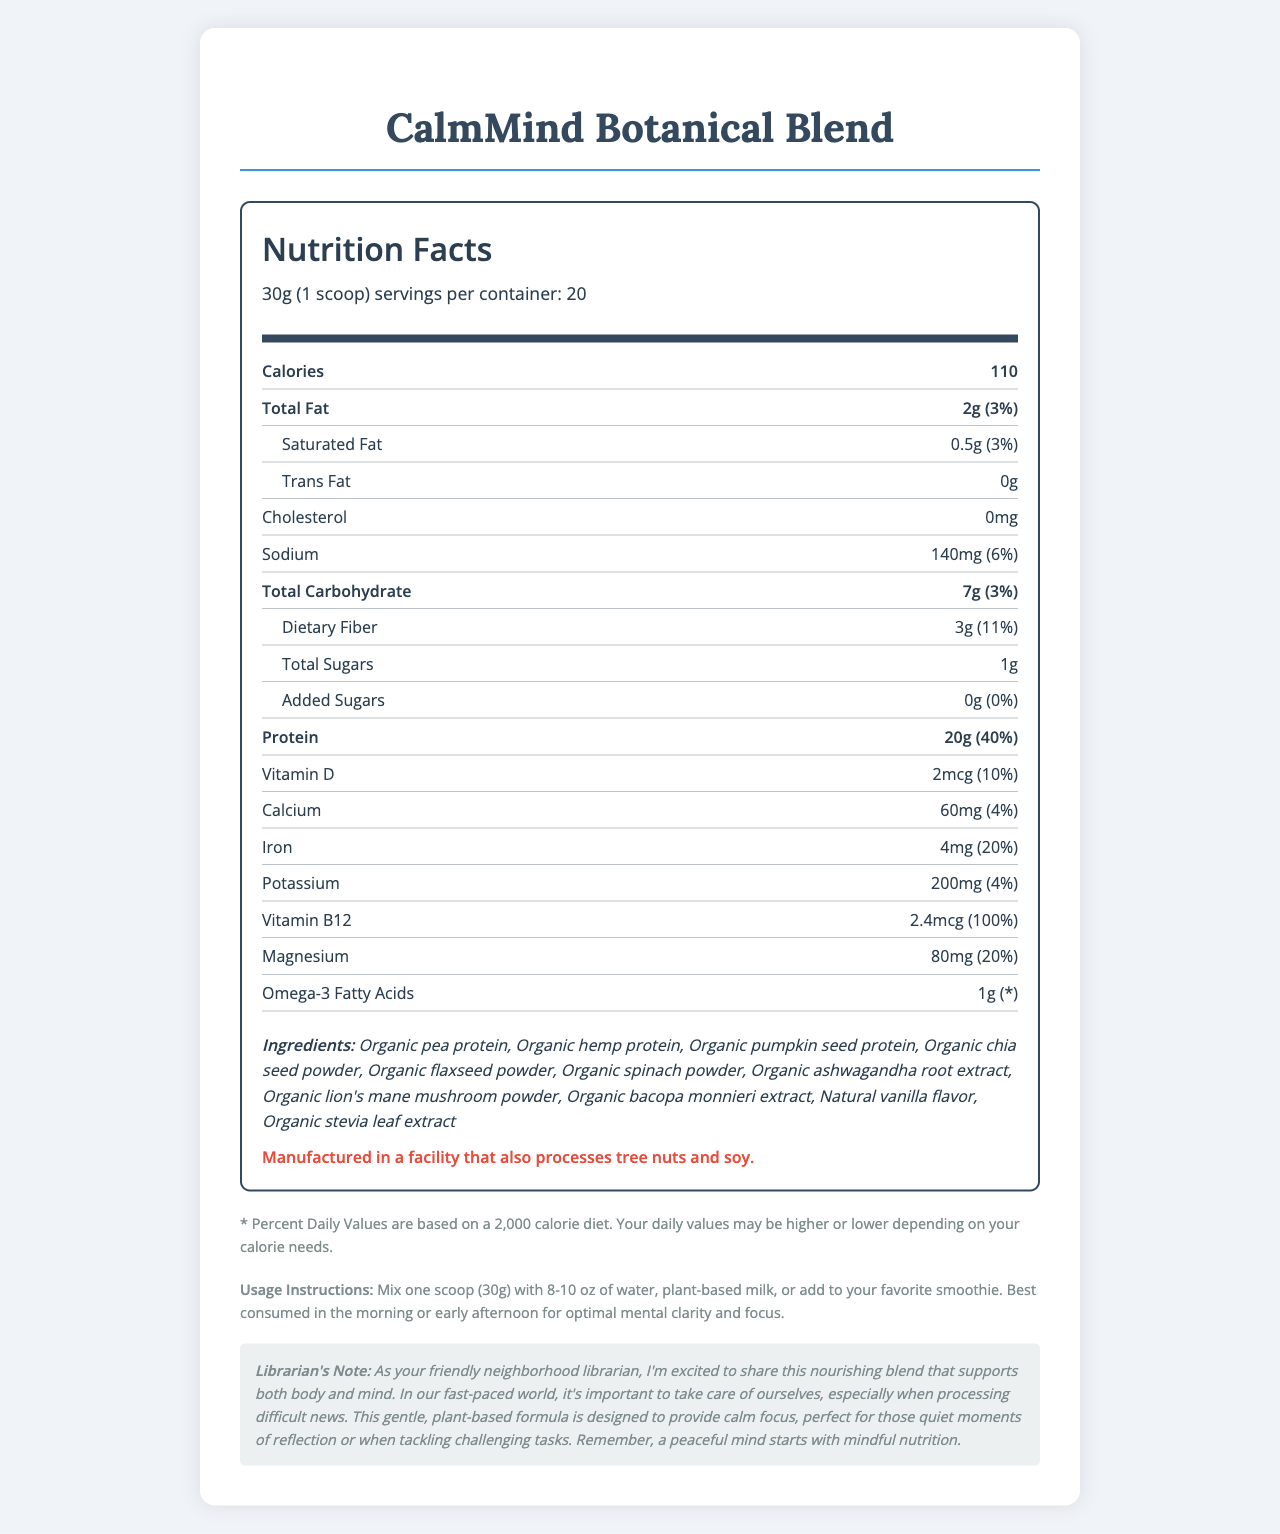who produces CalmMind Botanical Blend? The document does not provide information about the producer or manufacturer of CalmMind Botanical Blend.
Answer: Cannot be determined what is the serving size for CalmMind Botanical Blend? The document specifies that one serving of CalmMind Botanical Blend is 30 grams, which is equivalent to one scoop.
Answer: 30g (1 scoop) how many calories are in one serving of CalmMind Botanical Blend? The document states that there are 110 calories in one serving of CalmMind Botanical Blend.
Answer: 110 what is the total amount of protein per serving? The document indicates that one serving of CalmMind Botanical Blend contains 20 grams of protein.
Answer: 20g what percentage of the daily value for dietary fiber does one serving provide? The document shows that one serving provides 11% of the daily value for dietary fiber.
Answer: 11% how many servings are in one container of CalmMind Botanical Blend? The document indicates there are 20 servings per container.
Answer: 20 what is the amount of added sugars in CalmMind Botanical Blend per serving? The document states that there are no added sugars (0g) per serving.
Answer: 0g how much iron does one serving provide, and what is its daily value percentage? The document specifies that one serving contains 4mg of iron, which is 20% of the daily value.
Answer: 4mg, 20% what is the amount of omega-3 fatty acids in one serving? The document indicates that there is 1 gram of omega-3 fatty acids in one serving of CalmMind Botanical Blend.
Answer: 1g is the product cholesterol-free? The document clearly states that there is 0mg of cholesterol in CalmMind Botanical Blend.
Answer: Yes which of the following ingredients is NOT listed in CalmMind Botanical Blend? A. Organic pea protein B. Organic stevia leaf extract C. Organic whey protein D. Organic hemp protein Organic whey protein is not listed as an ingredient in CalmMind Botanical Blend.
Answer: C how much magnesium is in each serving, and what percentage of the daily value does this represent? A. 40mg, 10% B. 60mg, 15% C. 80mg, 20% D. 100mg, 25% According to the document, each serving contains 80mg of magnesium, which represents 20% of the daily value.
Answer: C the product is manufactured in a facility that processes which allergens? A. Peanuts B. Tree nuts and soy C. Dairy and gluten D. None of the above The document mentions that the product is manufactured in a facility that also processes tree nuts and soy.
Answer: B does CalmMind Botanical Blend contain any animal-derived ingredients? The list of ingredients includes only plant-based components, such as organic pea protein, organic hemp protein, and various plant powders.
Answer: No describe the main idea of the document. The document outlines the nutritional profile of CalmMind Botanical Blend, highlighting that it is a nutrient-dense, plant-based protein powder aimed at enhancing mental clarity and focus. It also includes ingredient details, allergen warnings, and usage guidelines. Additionally, a personal note from the librarian emphasizes the product's suitability for maintaining calm and focus during stressful times.
Answer: The document provides detailed nutrition facts and other relevant information about CalmMind Botanical Blend, a plant-based protein powder designed to support mental clarity and focus. It includes nutritional content per serving, a list of ingredients, allergen information, usage instructions, and a personal note from a librarian. what are the usage instructions for CalmMind Botanical Blend? The document instructs users to mix one scoop (30 grams) of the blend with 8-10 ounces of water, plant-based milk, or a smoothie. It suggests consuming it in the morning or early afternoon for optimal mental clarity and focus.
Answer: Mix one scoop (30g) with 8-10 oz of water, plant-based milk, or add to your favorite smoothie. Best consumed in the morning or early afternoon for optimal mental clarity and focus. what is the librarian's note about CalmMind Botanical Blend? The librarian emphasizes the product's benefits for mental and physical well-being, highlighting its role in providing calm focus and mindful nutrition, particularly during stressful times.
Answer: The librarian notes that CalmMind Botanical Blend is a nourishing blend supporting both body and mind, designed to provide calm focus, perfect for quiet moments of reflection or challenging tasks. It's important to take care of oneself, especially when processing difficult news. 